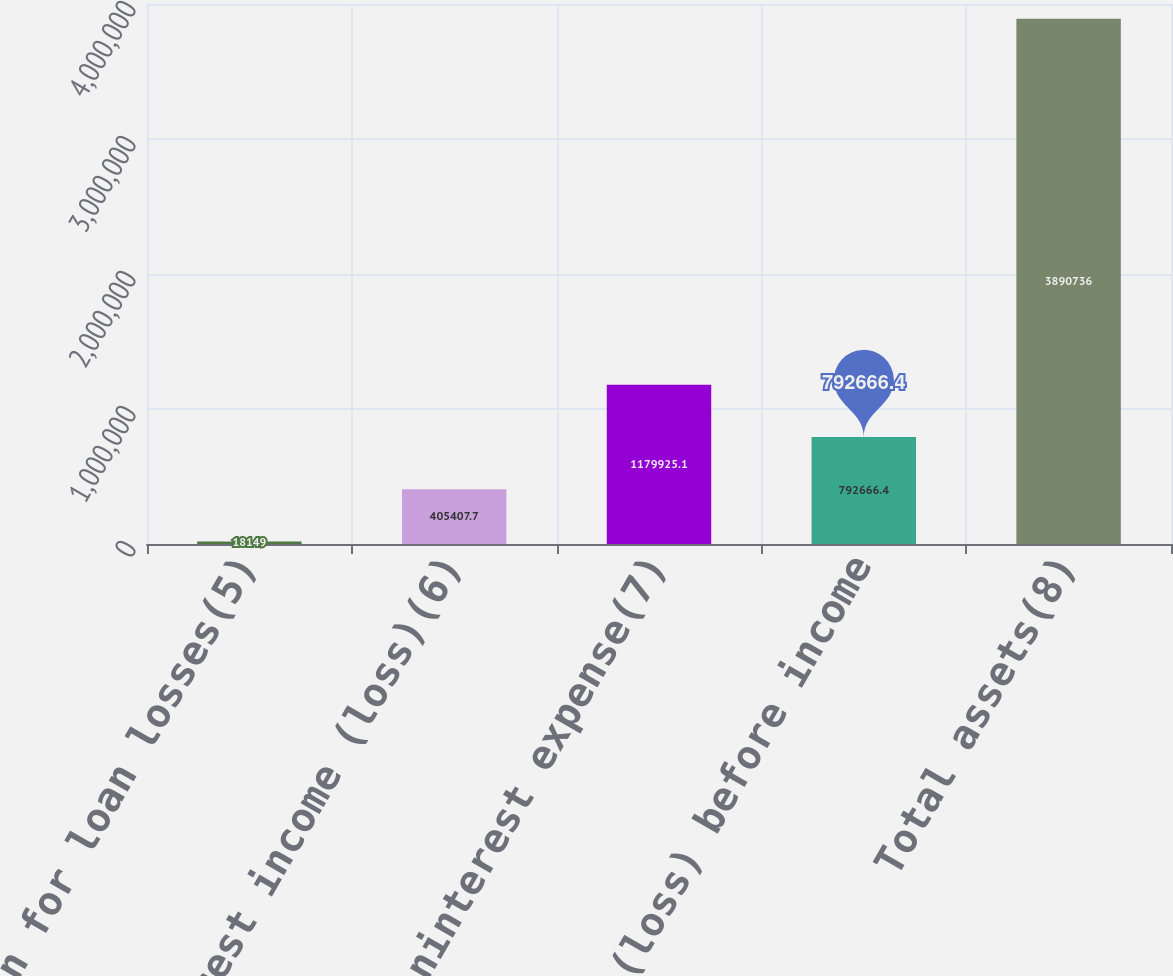Convert chart to OTSL. <chart><loc_0><loc_0><loc_500><loc_500><bar_chart><fcel>Provision for loan losses(5)<fcel>Noninterest income (loss)(6)<fcel>Noninterest expense(7)<fcel>Income (loss) before income<fcel>Total assets(8)<nl><fcel>18149<fcel>405408<fcel>1.17993e+06<fcel>792666<fcel>3.89074e+06<nl></chart> 